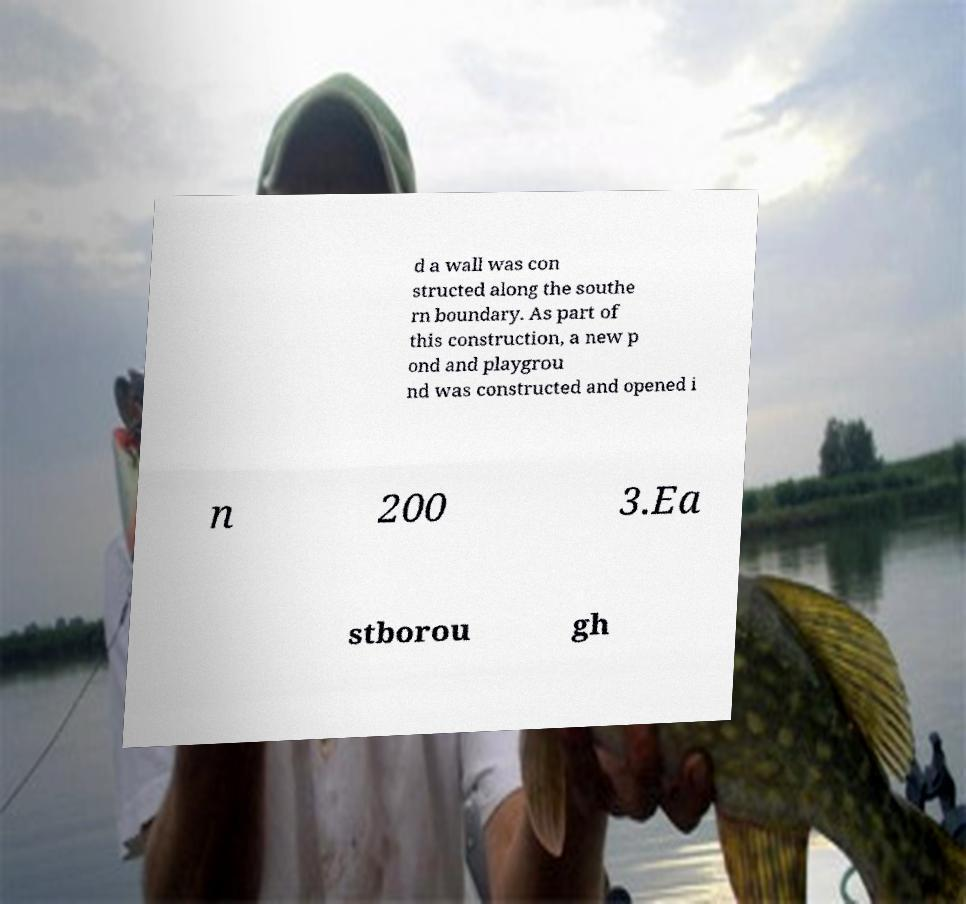Can you accurately transcribe the text from the provided image for me? d a wall was con structed along the southe rn boundary. As part of this construction, a new p ond and playgrou nd was constructed and opened i n 200 3.Ea stborou gh 